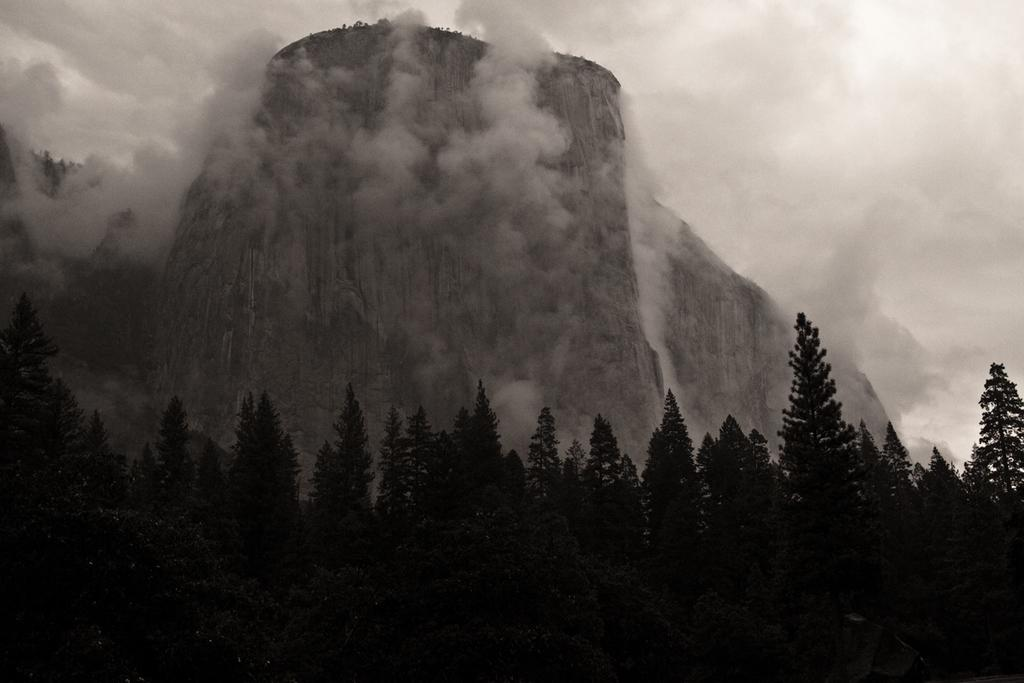What type of natural vegetation can be seen in the image? There are trees in the image. What is the presence of smoke suggesting in the image? The smoke visible in the image suggests that there might be a fire or some form of combustion occurring. What part of the natural environment is visible in the image? The sky is visible in the image. What is the color scheme of the image? The image is black and white in color. Can you see an umbrella being used to catch the smoke in the image? There is no umbrella present in the image, and the smoke is not being caught by any object. What type of roll is being performed by the trees in the image? There is no roll being performed by the trees in the image; they are stationary. 